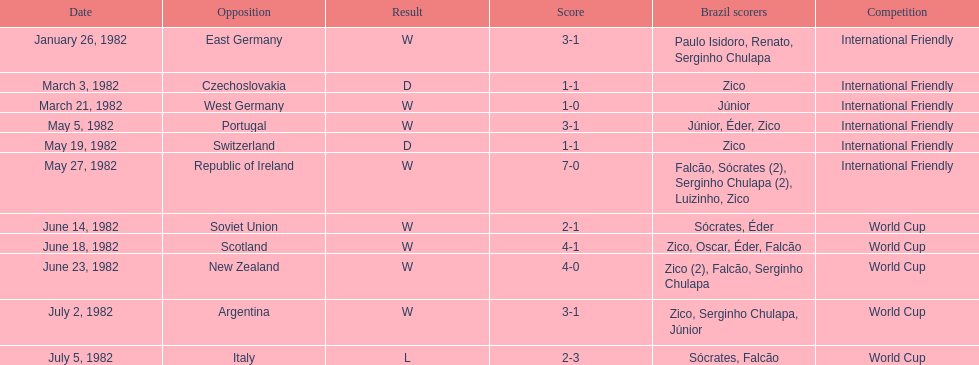How many losses did brazil endure in total? 1. 